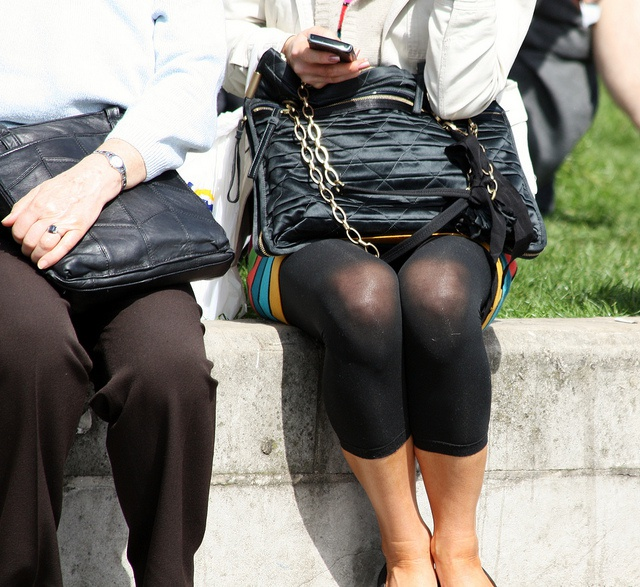Describe the objects in this image and their specific colors. I can see people in white, black, and gray tones, people in white, black, and gray tones, handbag in white, black, gray, darkgray, and purple tones, handbag in white, gray, black, and darkgray tones, and people in white, black, ivory, gray, and darkgray tones in this image. 